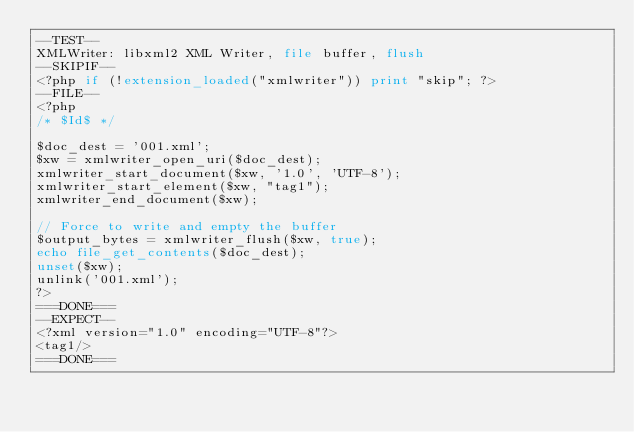<code> <loc_0><loc_0><loc_500><loc_500><_PHP_>--TEST--
XMLWriter: libxml2 XML Writer, file buffer, flush
--SKIPIF--
<?php if (!extension_loaded("xmlwriter")) print "skip"; ?>
--FILE--
<?php
/* $Id$ */

$doc_dest = '001.xml';
$xw = xmlwriter_open_uri($doc_dest);
xmlwriter_start_document($xw, '1.0', 'UTF-8');
xmlwriter_start_element($xw, "tag1");
xmlwriter_end_document($xw);

// Force to write and empty the buffer
$output_bytes = xmlwriter_flush($xw, true);
echo file_get_contents($doc_dest);
unset($xw);
unlink('001.xml');
?>
===DONE===
--EXPECT--
<?xml version="1.0" encoding="UTF-8"?>
<tag1/>
===DONE===
</code> 